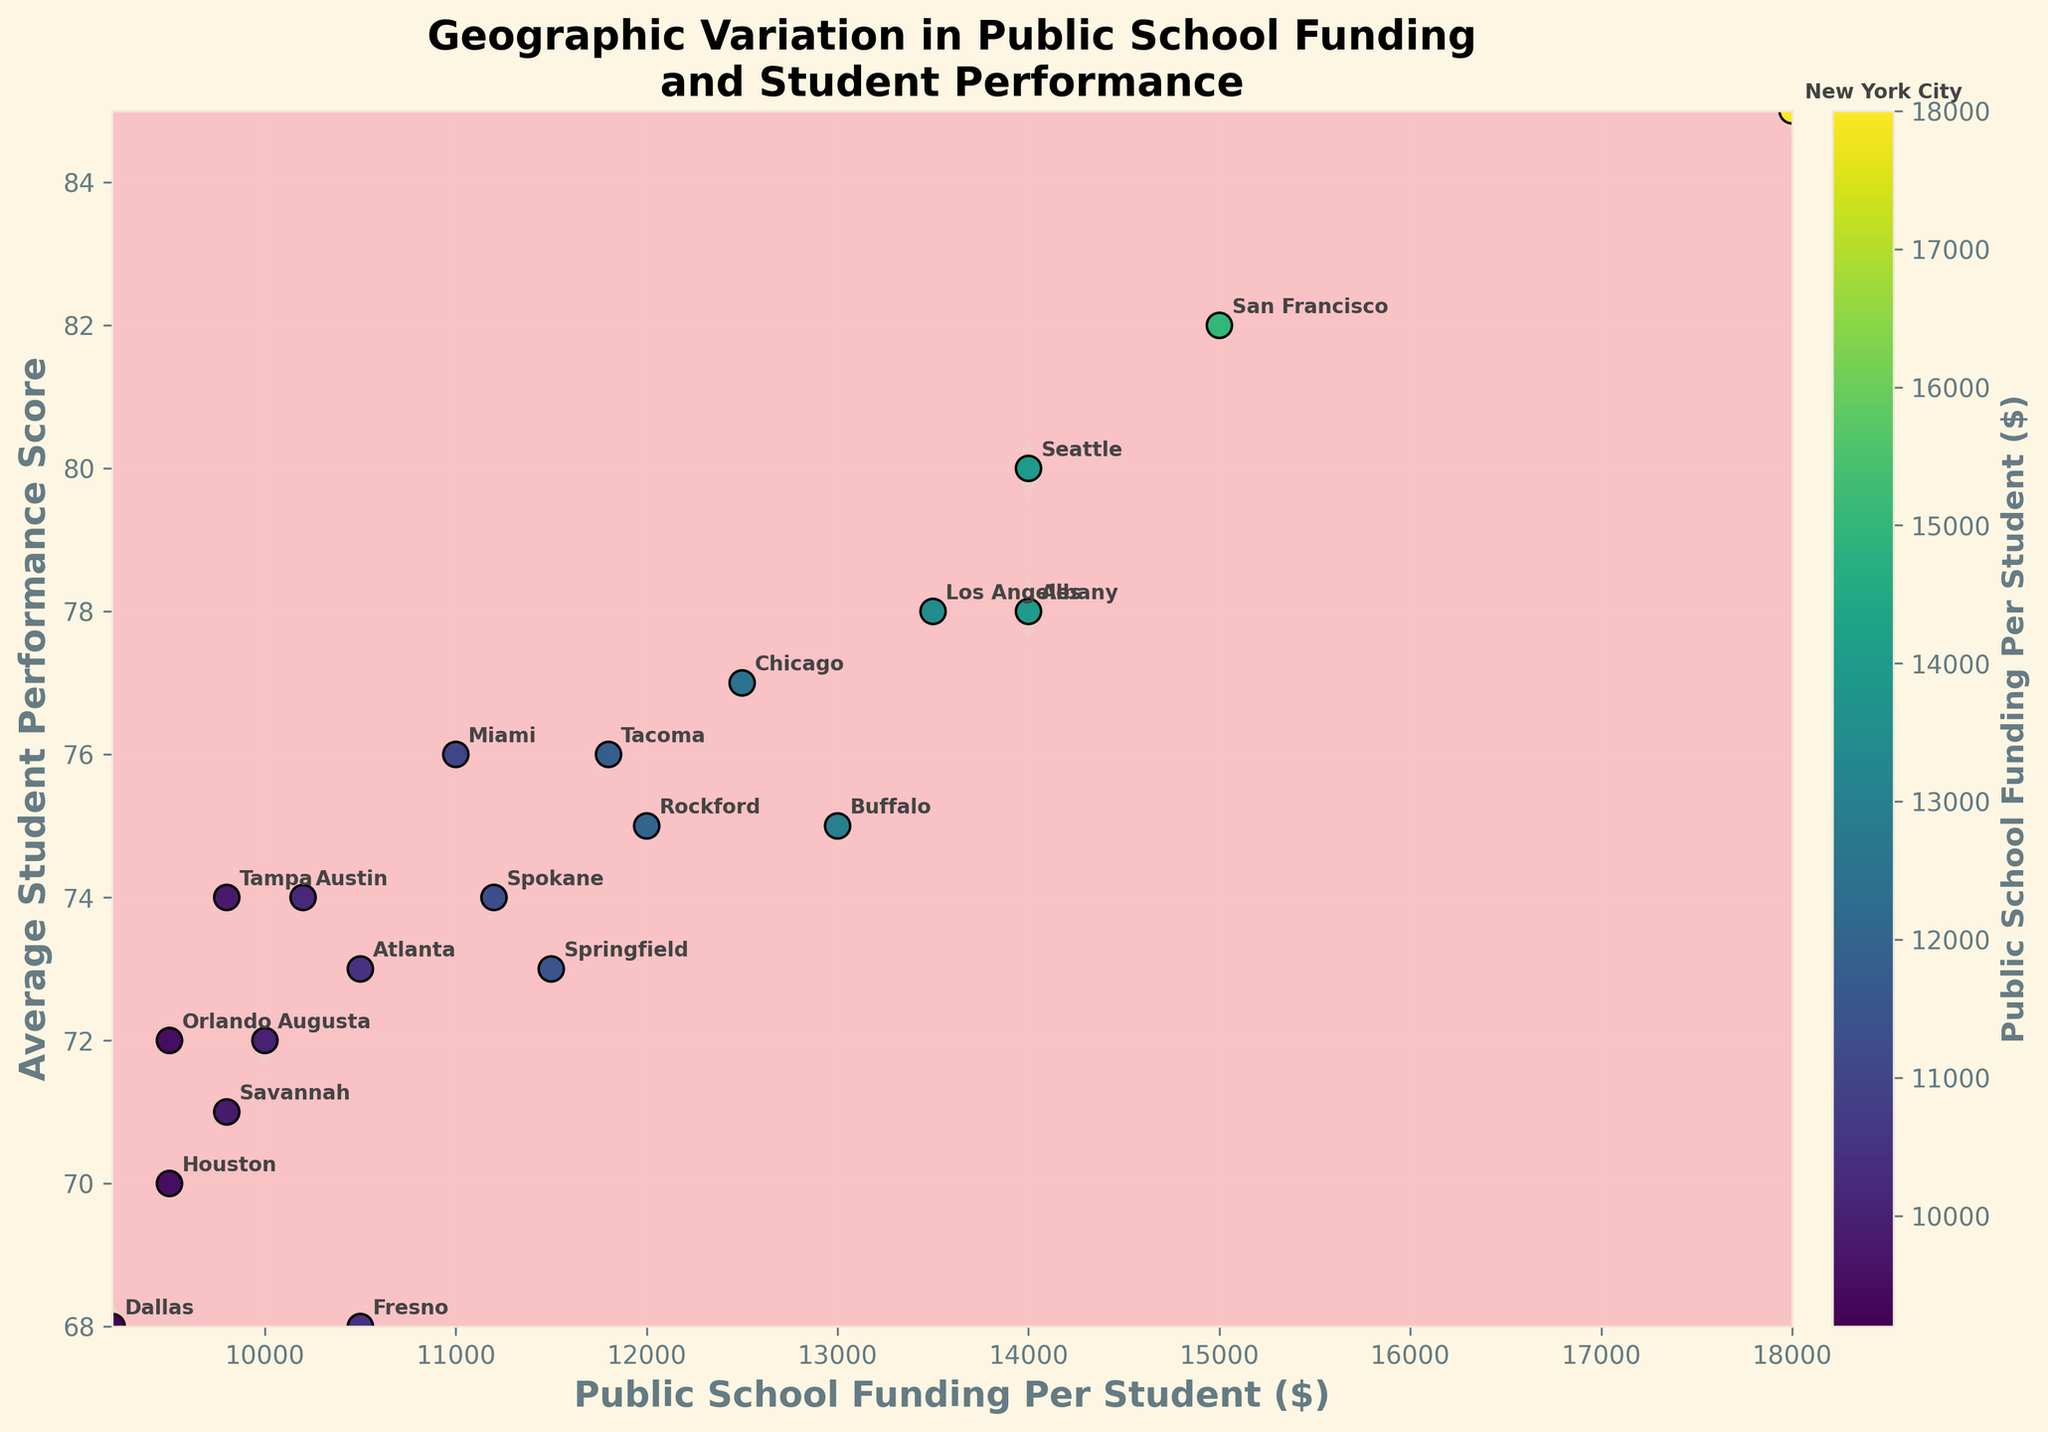What is the title of the plot? The title of the plot is located at the top center and describes the main topic of the plot. It reads "Geographic Variation in Public School Funding and Student Performance."
Answer: Geographic Variation in Public School Funding and Student Performance What color represents higher public school funding per student in the scatter plot? The scatter plot uses a color gradient where higher funding per student is represented by lighter colors. The color bar to the right of the plot indicates this, with higher funding having lighter shades in the 'viridis' colormap.
Answer: Lighter colors Which county has the highest average student performance score? By looking at the scatter points and annotations, the point with the highest performance score is annotated with "New York City," which is located at the top right of the plot.
Answer: New York City Are there more counties with public school funding below $10,000 or above $10,000? To determine this, count the number of scatter points on each side of the $10,000 mark on the x-axis.
Answer: Above $10,000 What does the contour shading represent in the plot? The contour shading represents the density of data points. The contours are filled based on how closely packed the points are, with different shades indicating the varying densities.
Answer: Density of data points Which state has the majority of its counties' average student performance scores above 75? Observing the scatter points and their annotations, New York has New York City, Buffalo, and Albany with performance scores above 75.
Answer: New York How many counties have a public school funding per student between $9,000 and $12,000? Count the scatter points that fall between the $9,000 and $12,000 marks on the x-axis.
Answer: Nine counties What is the general trend between public school funding per student and average student performance score? Observing the scatter plot, there is a positive correlation; higher funding per student generally associates with higher average student performance scores.
Answer: Positive correlation Which county has the closest combination of funding and performance to the national average indicated by the center of the density contour? Identify the county closest to the densest region of the contour. Chicago, with funding of $12,500 and a performance score of 77, fits this description.
Answer: Chicago 